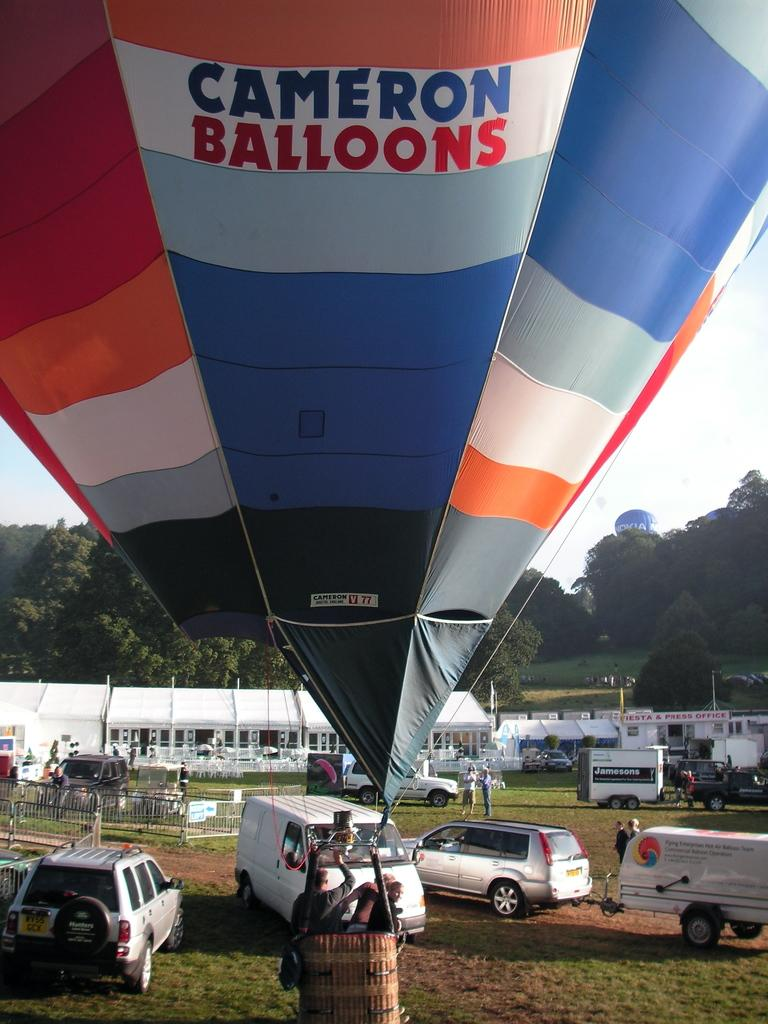<image>
Render a clear and concise summary of the photo. The hot air balloon giving rides today is from Cameron Balloons. 